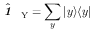<formula> <loc_0><loc_0><loc_500><loc_500>\hat { 1 \, } _ { \, Y } = \sum _ { y } | y \rangle \langle y |</formula> 